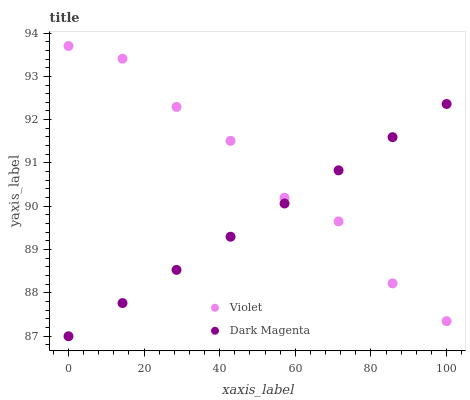Does Dark Magenta have the minimum area under the curve?
Answer yes or no. Yes. Does Violet have the maximum area under the curve?
Answer yes or no. Yes. Does Violet have the minimum area under the curve?
Answer yes or no. No. Is Dark Magenta the smoothest?
Answer yes or no. Yes. Is Violet the roughest?
Answer yes or no. Yes. Is Violet the smoothest?
Answer yes or no. No. Does Dark Magenta have the lowest value?
Answer yes or no. Yes. Does Violet have the lowest value?
Answer yes or no. No. Does Violet have the highest value?
Answer yes or no. Yes. Does Dark Magenta intersect Violet?
Answer yes or no. Yes. Is Dark Magenta less than Violet?
Answer yes or no. No. Is Dark Magenta greater than Violet?
Answer yes or no. No. 